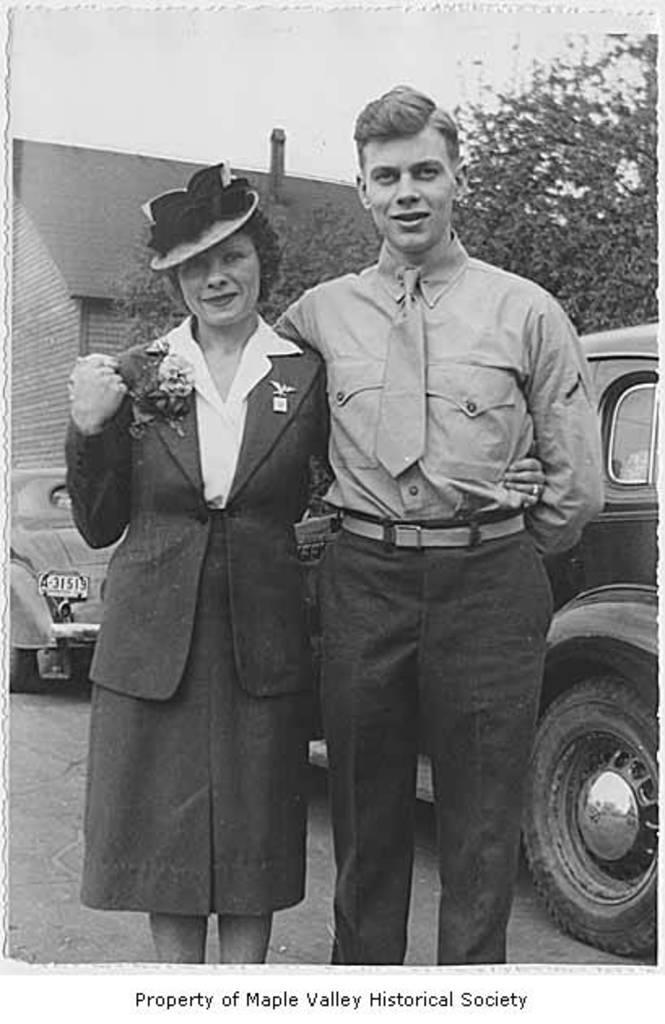Who can be seen in the image? There is a couple standing in the image. What is the color scheme of the image? The image is in black and white. What can be seen behind the couple? There are two vehicles and a building visible in the background. What type of vegetation is present in the background? There is a tree in the background. What else can be seen in the background of the image? The sky is visible in the background. What is the chance of the couple washing the brick in the image? There is no mention of a brick or washing in the image, so it is not possible to determine the chance of such an event occurring. 